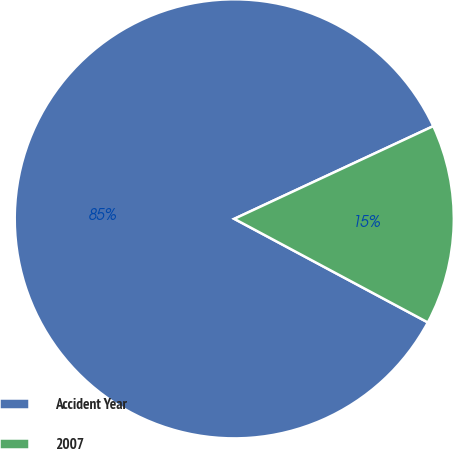<chart> <loc_0><loc_0><loc_500><loc_500><pie_chart><fcel>Accident Year<fcel>2007<nl><fcel>85.24%<fcel>14.76%<nl></chart> 